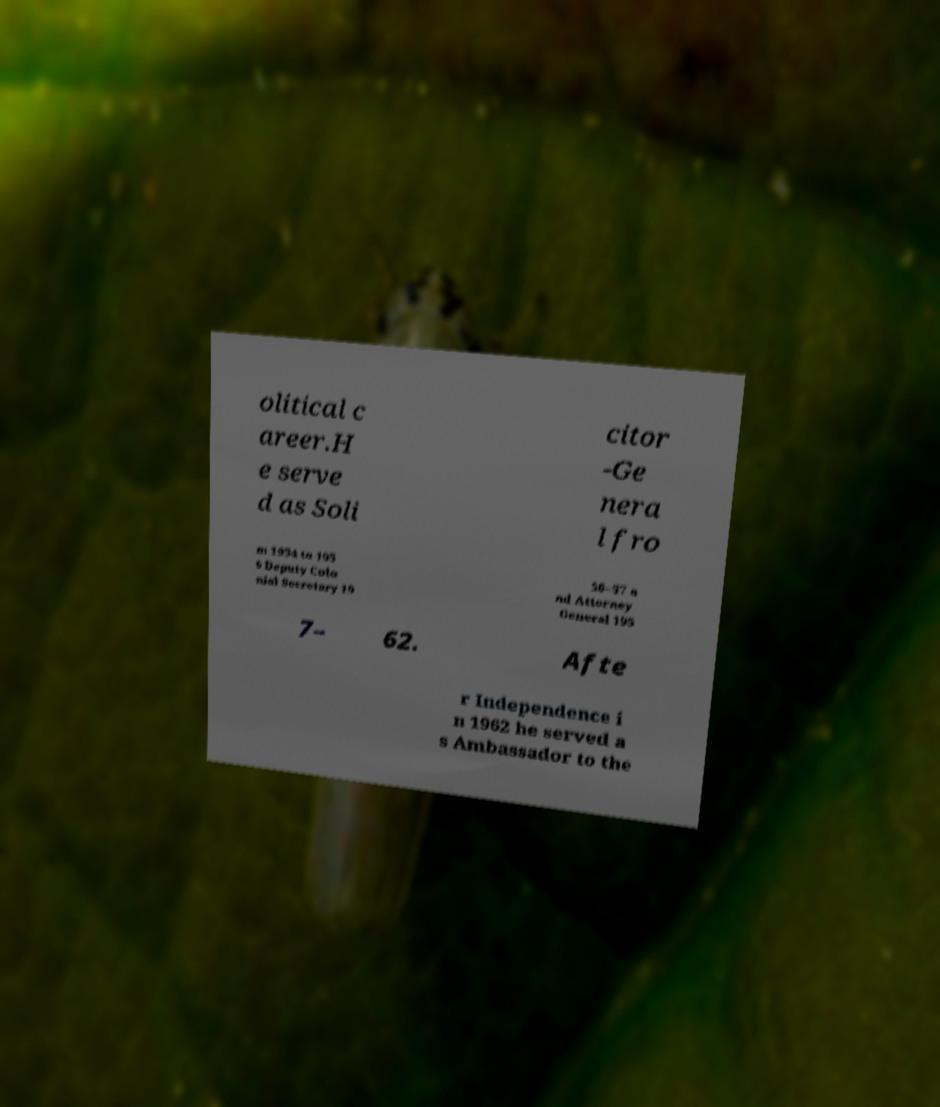For documentation purposes, I need the text within this image transcribed. Could you provide that? olitical c areer.H e serve d as Soli citor -Ge nera l fro m 1954 to 195 6 Deputy Colo nial Secretary 19 56–57 a nd Attorney General 195 7– 62. Afte r Independence i n 1962 he served a s Ambassador to the 